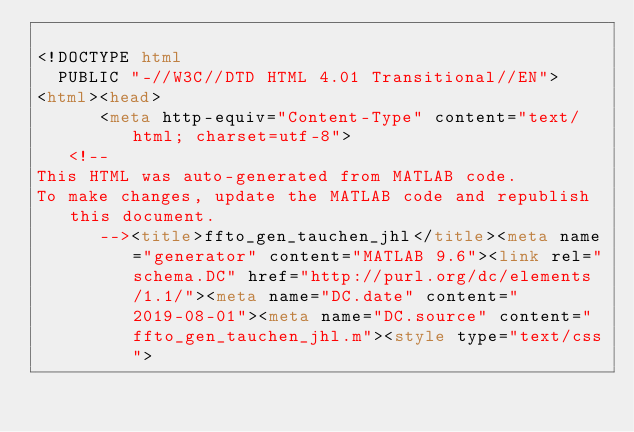Convert code to text. <code><loc_0><loc_0><loc_500><loc_500><_HTML_>
<!DOCTYPE html
  PUBLIC "-//W3C//DTD HTML 4.01 Transitional//EN">
<html><head>
      <meta http-equiv="Content-Type" content="text/html; charset=utf-8">
   <!--
This HTML was auto-generated from MATLAB code.
To make changes, update the MATLAB code and republish this document.
      --><title>ffto_gen_tauchen_jhl</title><meta name="generator" content="MATLAB 9.6"><link rel="schema.DC" href="http://purl.org/dc/elements/1.1/"><meta name="DC.date" content="2019-08-01"><meta name="DC.source" content="ffto_gen_tauchen_jhl.m"><style type="text/css"></code> 